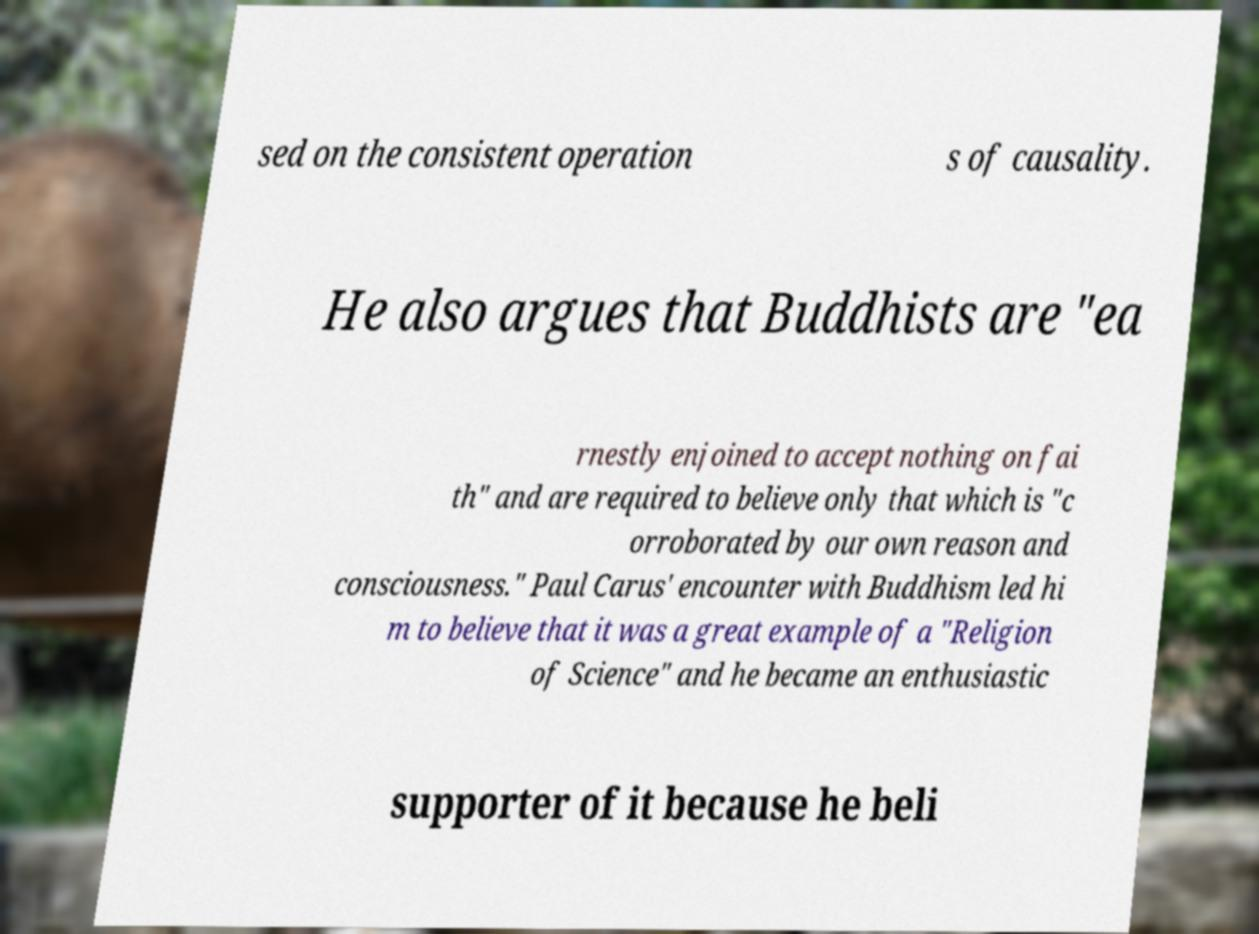Could you assist in decoding the text presented in this image and type it out clearly? sed on the consistent operation s of causality. He also argues that Buddhists are "ea rnestly enjoined to accept nothing on fai th" and are required to believe only that which is "c orroborated by our own reason and consciousness." Paul Carus' encounter with Buddhism led hi m to believe that it was a great example of a "Religion of Science" and he became an enthusiastic supporter of it because he beli 